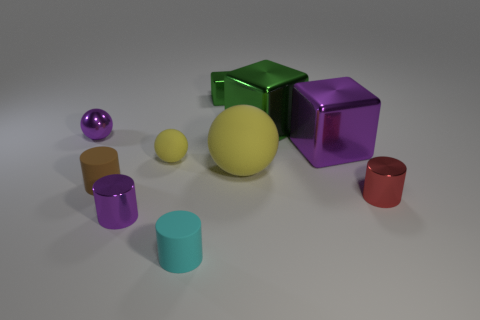Subtract all blocks. How many objects are left? 7 Subtract 0 red balls. How many objects are left? 10 Subtract all brown matte things. Subtract all yellow things. How many objects are left? 7 Add 2 green cubes. How many green cubes are left? 4 Add 8 gray rubber cylinders. How many gray rubber cylinders exist? 8 